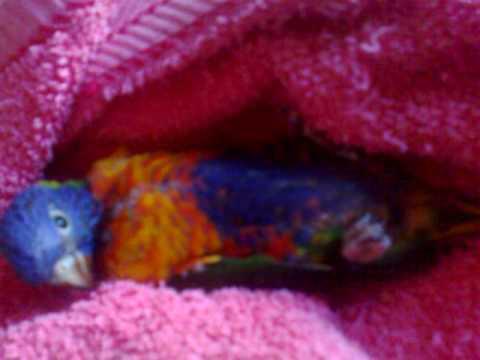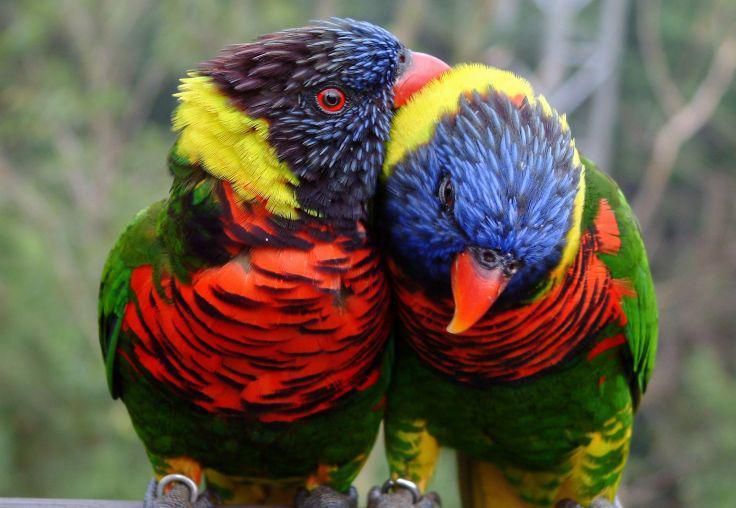The first image is the image on the left, the second image is the image on the right. Evaluate the accuracy of this statement regarding the images: "There are three parrots.". Is it true? Answer yes or no. Yes. The first image is the image on the left, the second image is the image on the right. For the images displayed, is the sentence "There are four colorful birds in the pair of images." factually correct? Answer yes or no. No. 